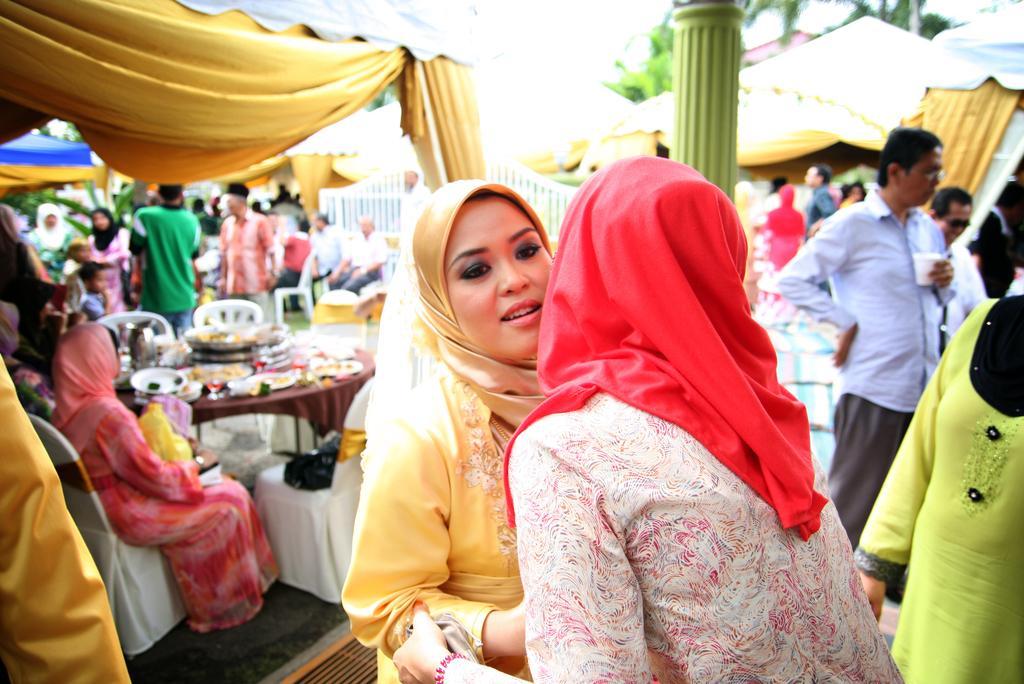Please provide a concise description of this image. In this image I can see few people are standing and few people are sitting on the chairs. I can see few plates,food items and few objects on the table. I can see pillars,cream curtains and trees. 